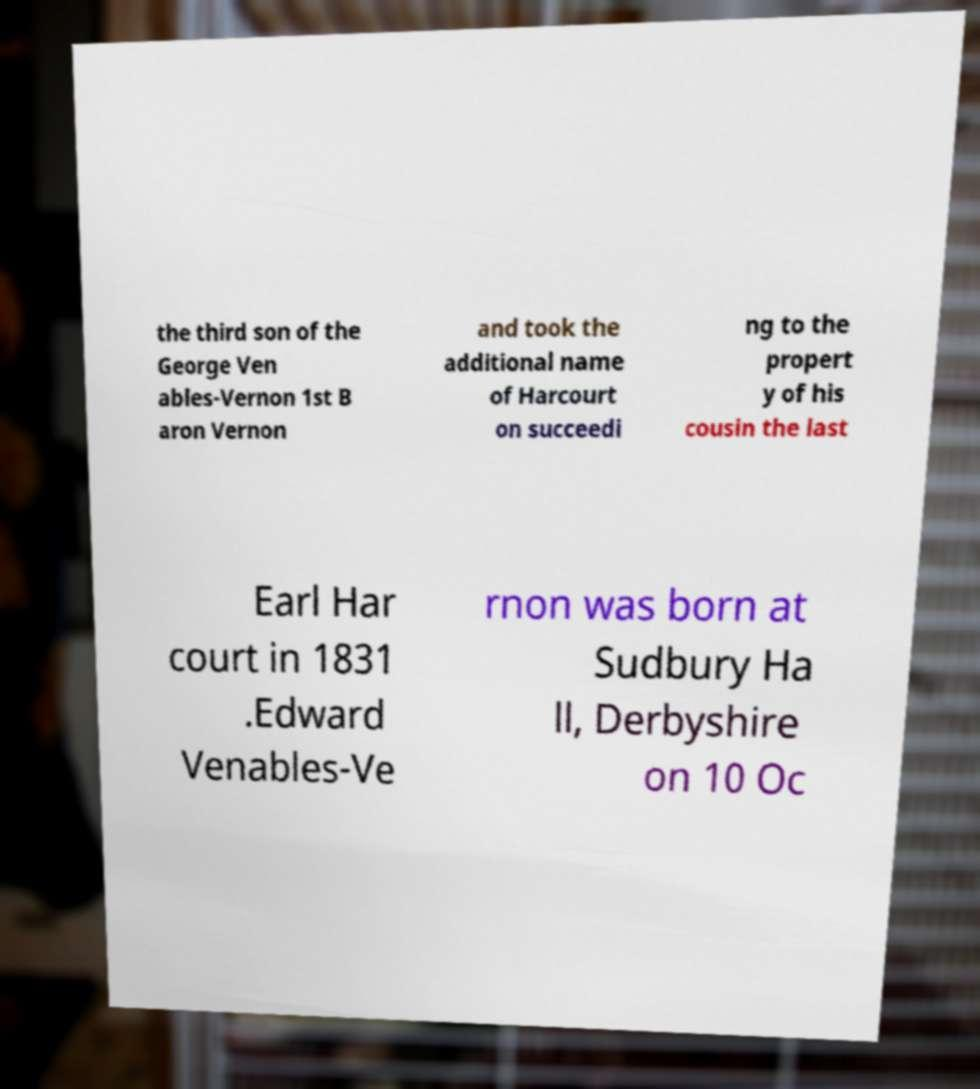For documentation purposes, I need the text within this image transcribed. Could you provide that? the third son of the George Ven ables-Vernon 1st B aron Vernon and took the additional name of Harcourt on succeedi ng to the propert y of his cousin the last Earl Har court in 1831 .Edward Venables-Ve rnon was born at Sudbury Ha ll, Derbyshire on 10 Oc 